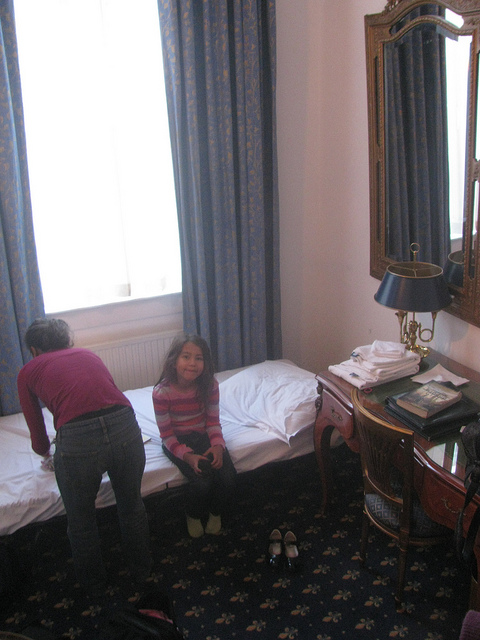How many people are in the room? There are two people in the room, one standing by the bed facing away and one sitting on the bed smiling towards the camera. 